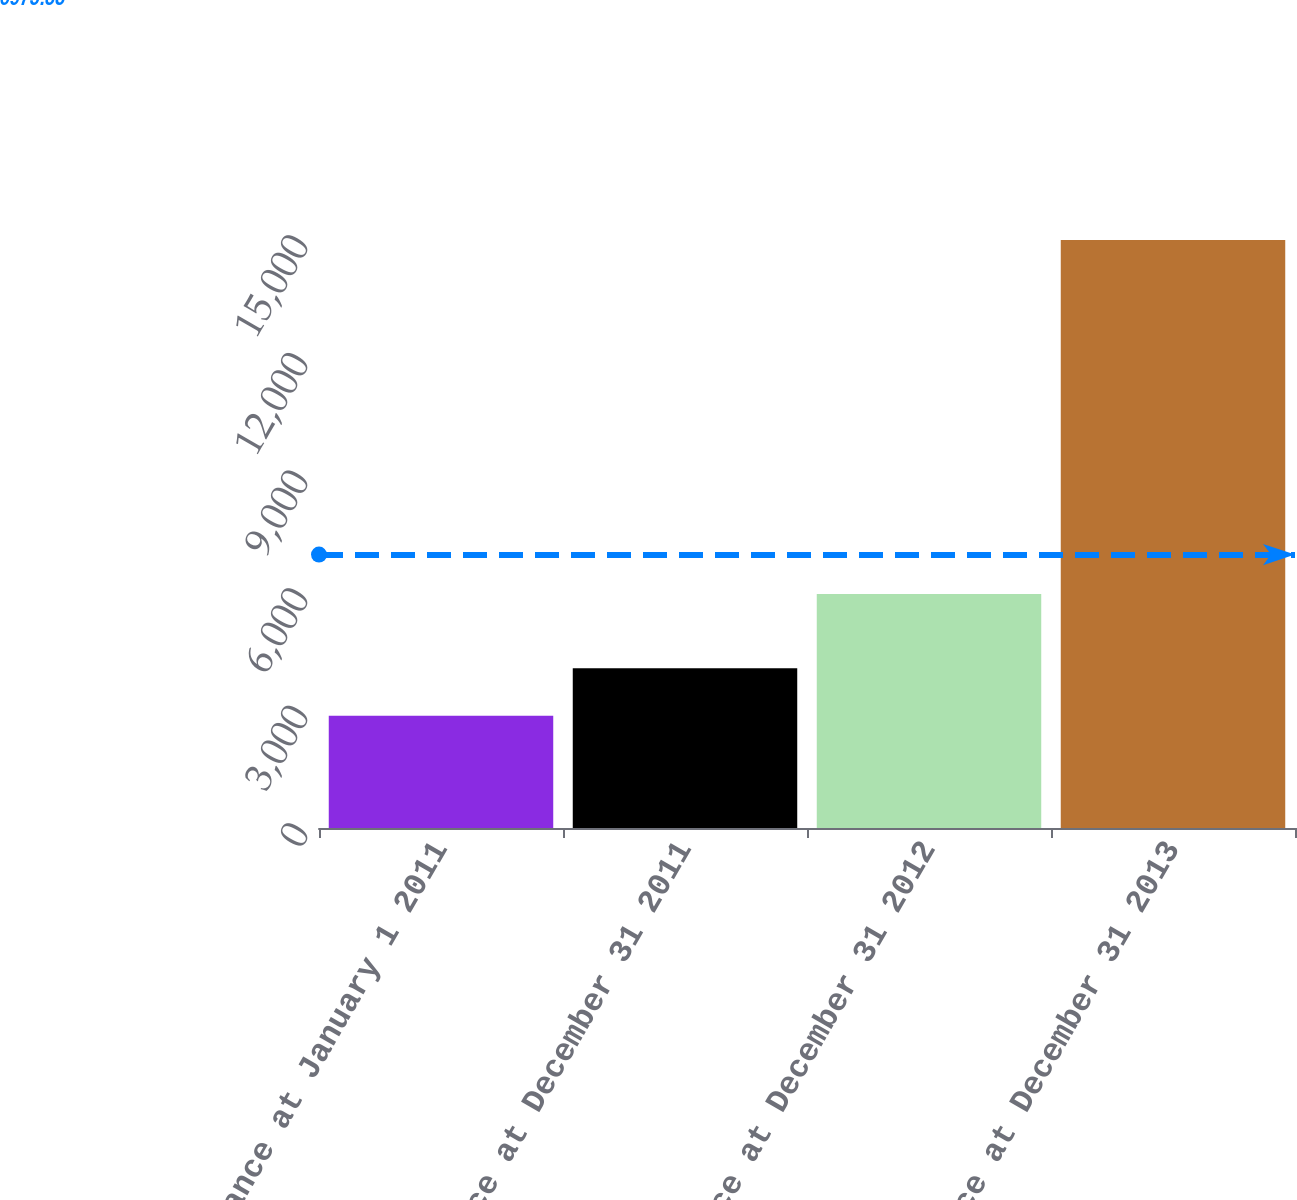<chart> <loc_0><loc_0><loc_500><loc_500><bar_chart><fcel>Balance at January 1 2011<fcel>Balance at December 31 2011<fcel>Balance at December 31 2012<fcel>Balance at December 31 2013<nl><fcel>2862<fcel>4075.5<fcel>5967<fcel>14997<nl></chart> 